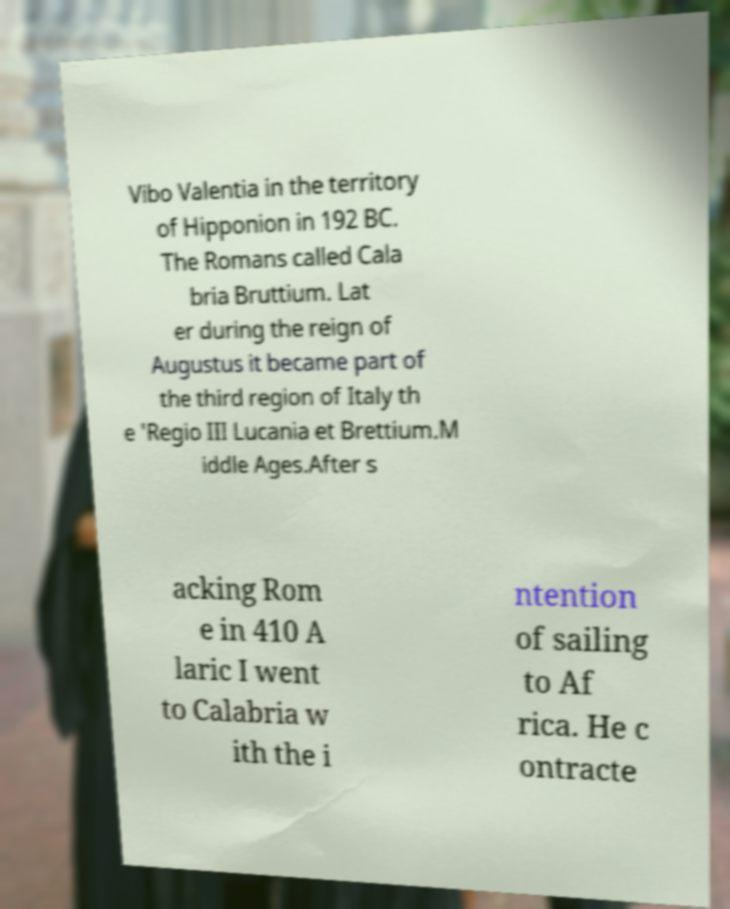Please read and relay the text visible in this image. What does it say? Vibo Valentia in the territory of Hipponion in 192 BC. The Romans called Cala bria Bruttium. Lat er during the reign of Augustus it became part of the third region of Italy th e 'Regio III Lucania et Brettium.M iddle Ages.After s acking Rom e in 410 A laric I went to Calabria w ith the i ntention of sailing to Af rica. He c ontracte 